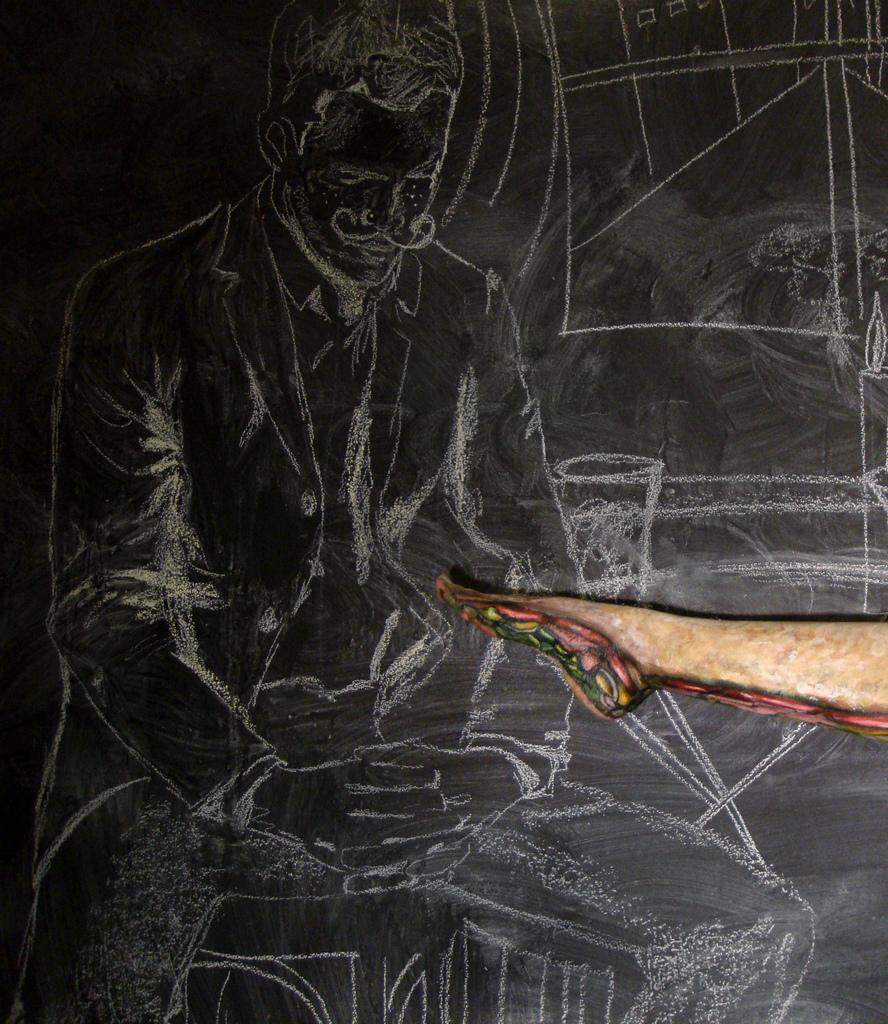What is the man in the image doing? The man in the image is sketching. What is the color of the surface being sketched on? The surface being sketched on is black. What can be seen on the right side of the image? There is a human leg depicted on the right side of the image. Can you tell me how many boats are visible in the image? There are no boats present in the image. How does the man touch the human leg in the image? The man is not touching the human leg in the image; he is sketching it. 